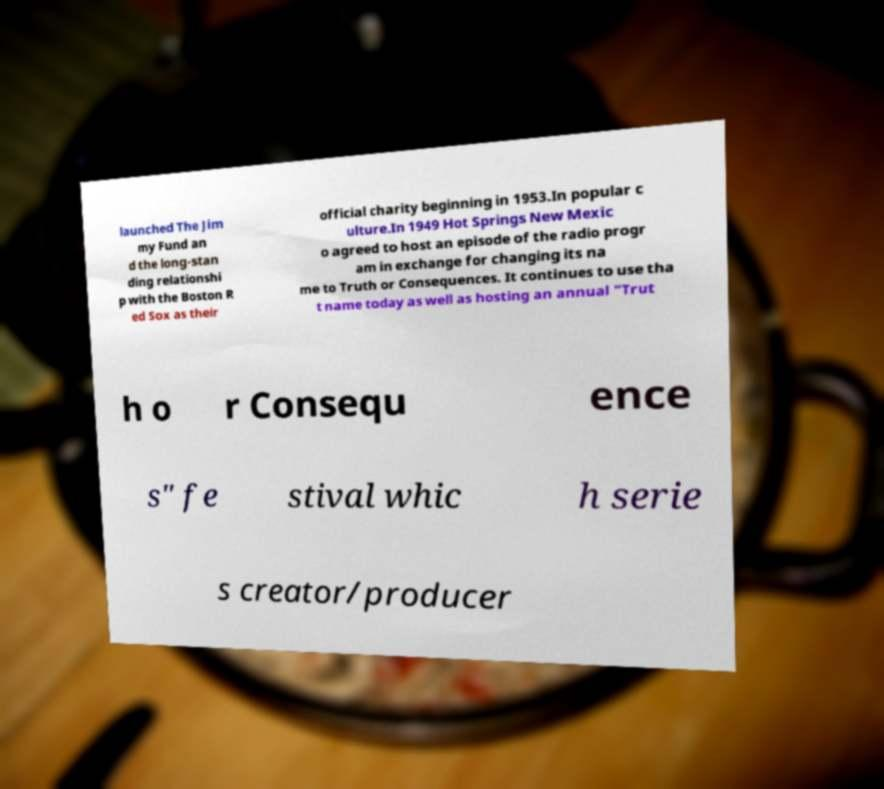Could you extract and type out the text from this image? launched The Jim my Fund an d the long-stan ding relationshi p with the Boston R ed Sox as their official charity beginning in 1953.In popular c ulture.In 1949 Hot Springs New Mexic o agreed to host an episode of the radio progr am in exchange for changing its na me to Truth or Consequences. It continues to use tha t name today as well as hosting an annual "Trut h o r Consequ ence s" fe stival whic h serie s creator/producer 